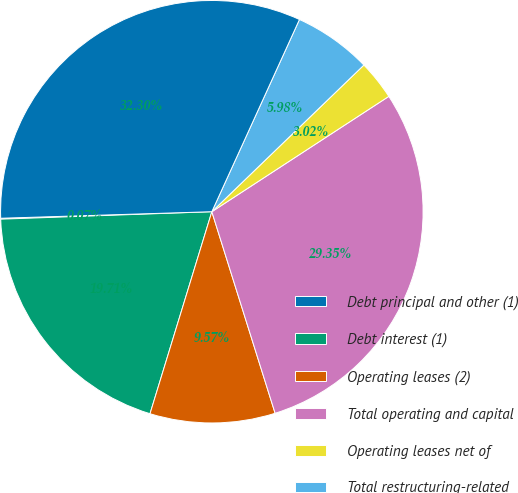<chart> <loc_0><loc_0><loc_500><loc_500><pie_chart><fcel>Debt principal and other (1)<fcel>Debt interest (1)<fcel>Operating leases (2)<fcel>Total operating and capital<fcel>Operating leases net of<fcel>Total restructuring-related<fcel>Total commitments<nl><fcel>0.07%<fcel>19.71%<fcel>9.57%<fcel>29.35%<fcel>3.02%<fcel>5.98%<fcel>32.3%<nl></chart> 